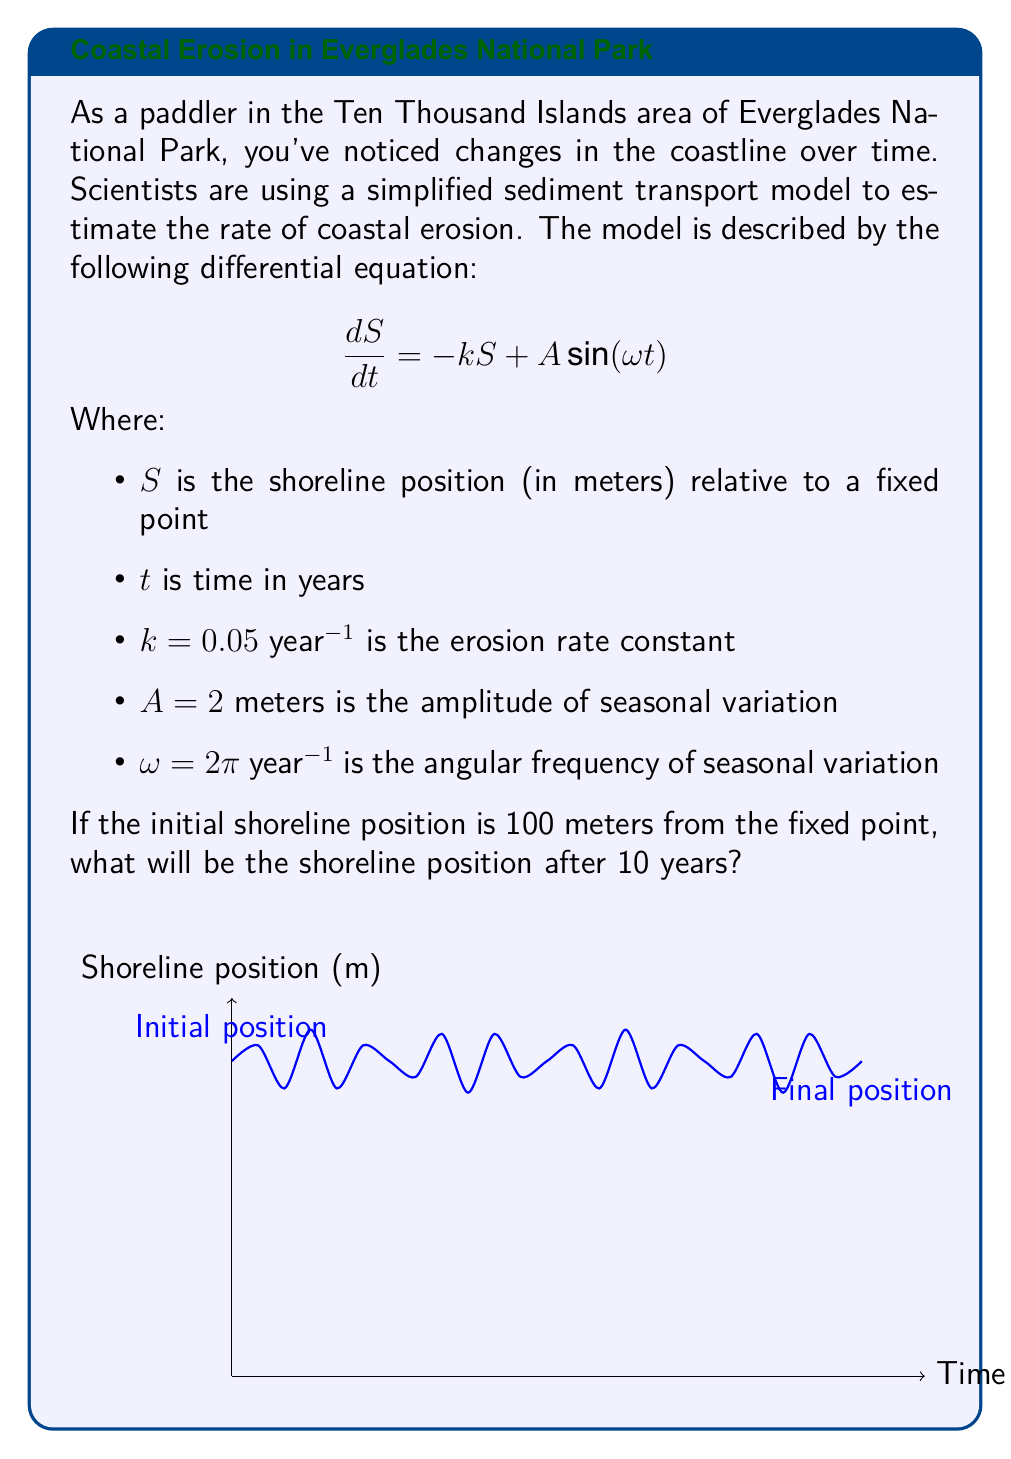Can you answer this question? To solve this problem, we need to follow these steps:

1) The general solution to this differential equation is:

   $$S(t) = Ce^{-kt} + \frac{A}{\sqrt{k^2 + \omega^2}}[\frac{k}{\sqrt{k^2 + \omega^2}}\sin(\omega t) - \frac{\omega}{\sqrt{k^2 + \omega^2}}\cos(\omega t)] + \frac{A\omega}{k^2 + \omega^2}$$

   Where $C$ is a constant determined by the initial condition.

2) Given the initial condition $S(0) = 100$, we can find $C$:

   $$100 = C + \frac{-A\omega}{\sqrt{k^2 + \omega^2}} \cdot \frac{\omega}{\sqrt{k^2 + \omega^2}} + \frac{A\omega}{k^2 + \omega^2}$$

   $$C = 100 + \frac{A\omega^2}{(k^2 + \omega^2)^{3/2}}$$

3) Substituting the given values:

   $$C = 100 + \frac{2(2\pi)^2}{(0.05^2 + (2\pi)^2)^{3/2}} \approx 100.0064$$

4) Now we can write the full solution:

   $$S(t) = 100.0064e^{-0.05t} + \frac{2}{\sqrt{0.05^2 + (2\pi)^2}}[\frac{0.05}{\sqrt{0.05^2 + (2\pi)^2}}\sin(2\pi t) - \frac{2\pi}{\sqrt{0.05^2 + (2\pi)^2}}\cos(2\pi t)] + \frac{2(2\pi)}{0.05^2 + (2\pi)^2}$$

5) To find the position after 10 years, we evaluate $S(10)$:

   $$S(10) = 100.0064e^{-0.5} + \frac{2}{\sqrt{0.05^2 + (2\pi)^2}}[\frac{0.05}{\sqrt{0.05^2 + (2\pi)^2}}\sin(20\pi) - \frac{2\pi}{\sqrt{0.05^2 + (2\pi)^2}}\cos(20\pi)] + \frac{2(2\pi)}{0.05^2 + (2\pi)^2}$$

6) Calculating this (noting that $\sin(20\pi) = 0$ and $\cos(20\pi) = 1$):

   $$S(10) \approx 60.65 + 0 - 0.32 + 0.32 \approx 60.65$$

Therefore, after 10 years, the shoreline position will be approximately 60.65 meters from the fixed point.
Answer: 60.65 meters 